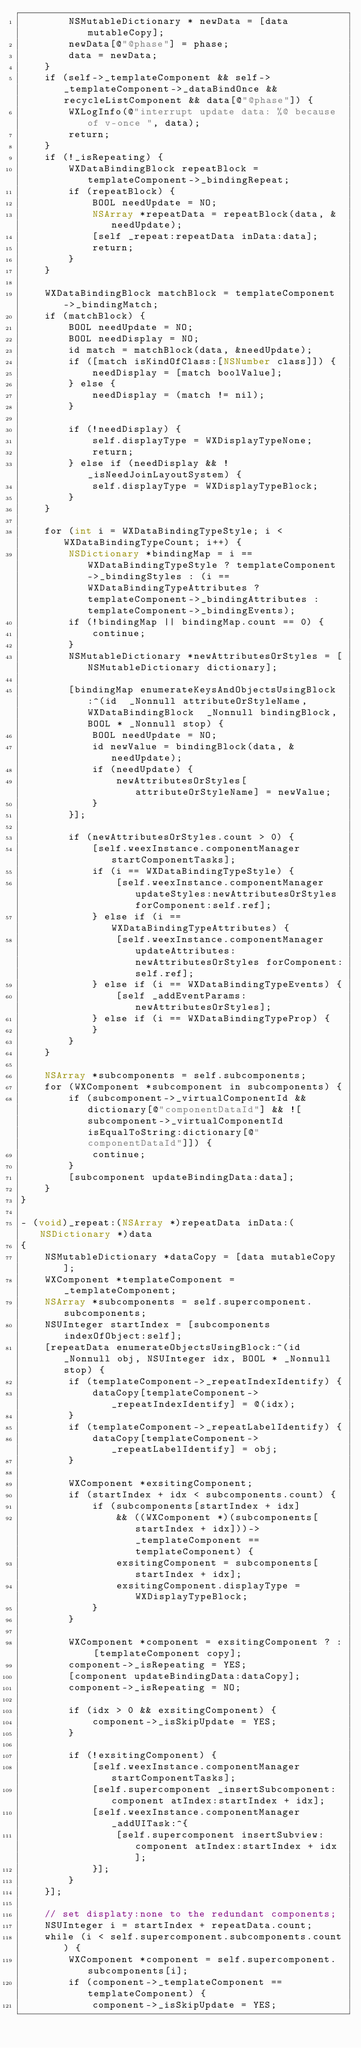Convert code to text. <code><loc_0><loc_0><loc_500><loc_500><_ObjectiveC_>        NSMutableDictionary * newData = [data mutableCopy];
        newData[@"@phase"] = phase;
        data = newData;
    }
    if (self->_templateComponent && self->_templateComponent->_dataBindOnce && recycleListComponent && data[@"@phase"]) {
        WXLogInfo(@"interrupt update data: %@ because of v-once ", data);
        return;
    }
    if (!_isRepeating) {
        WXDataBindingBlock repeatBlock = templateComponent->_bindingRepeat;
        if (repeatBlock) {
            BOOL needUpdate = NO;
            NSArray *repeatData = repeatBlock(data, &needUpdate);
            [self _repeat:repeatData inData:data];
            return;
        }
    }
    
    WXDataBindingBlock matchBlock = templateComponent->_bindingMatch;
    if (matchBlock) {
        BOOL needUpdate = NO;
        BOOL needDisplay = NO;
        id match = matchBlock(data, &needUpdate);
        if ([match isKindOfClass:[NSNumber class]]) {
            needDisplay = [match boolValue];
        } else {
            needDisplay = (match != nil);
        }
        
        if (!needDisplay) {
            self.displayType = WXDisplayTypeNone;
            return;
        } else if (needDisplay && !_isNeedJoinLayoutSystem) {
            self.displayType = WXDisplayTypeBlock;
        }
    }
    
    for (int i = WXDataBindingTypeStyle; i < WXDataBindingTypeCount; i++) {
        NSDictionary *bindingMap = i == WXDataBindingTypeStyle ? templateComponent->_bindingStyles : (i == WXDataBindingTypeAttributes ? templateComponent->_bindingAttributes : templateComponent->_bindingEvents);
        if (!bindingMap || bindingMap.count == 0) {
            continue;
        }
        NSMutableDictionary *newAttributesOrStyles = [NSMutableDictionary dictionary];
        
        [bindingMap enumerateKeysAndObjectsUsingBlock:^(id  _Nonnull attributeOrStyleName, WXDataBindingBlock  _Nonnull bindingBlock, BOOL * _Nonnull stop) {
            BOOL needUpdate = NO;
            id newValue = bindingBlock(data, &needUpdate);
            if (needUpdate) {
                newAttributesOrStyles[attributeOrStyleName] = newValue;
            }
        }];
        
        if (newAttributesOrStyles.count > 0) {
            [self.weexInstance.componentManager startComponentTasks];
            if (i == WXDataBindingTypeStyle) {
                [self.weexInstance.componentManager updateStyles:newAttributesOrStyles forComponent:self.ref];
            } else if (i == WXDataBindingTypeAttributes) {
                [self.weexInstance.componentManager updateAttributes:newAttributesOrStyles forComponent:self.ref];
            } else if (i == WXDataBindingTypeEvents) {
                [self _addEventParams:newAttributesOrStyles];
            } else if (i == WXDataBindingTypeProp) {
            }
        }
    }
    
    NSArray *subcomponents = self.subcomponents;
    for (WXComponent *subcomponent in subcomponents) {
        if (subcomponent->_virtualComponentId &&dictionary[@"componentDataId"] && ![subcomponent->_virtualComponentId isEqualToString:dictionary[@"componentDataId"]]) {
            continue;
        }
        [subcomponent updateBindingData:data];
    }
}

- (void)_repeat:(NSArray *)repeatData inData:(NSDictionary *)data
{
    NSMutableDictionary *dataCopy = [data mutableCopy];
    WXComponent *templateComponent = _templateComponent;
    NSArray *subcomponents = self.supercomponent.subcomponents;
    NSUInteger startIndex = [subcomponents indexOfObject:self];
    [repeatData enumerateObjectsUsingBlock:^(id  _Nonnull obj, NSUInteger idx, BOOL * _Nonnull stop) {
        if (templateComponent->_repeatIndexIdentify) {
            dataCopy[templateComponent->_repeatIndexIdentify] = @(idx);
        }
        if (templateComponent->_repeatLabelIdentify) {
            dataCopy[templateComponent->_repeatLabelIdentify] = obj;
        }
        
        WXComponent *exsitingComponent;
        if (startIndex + idx < subcomponents.count) {
            if (subcomponents[startIndex + idx]
                && ((WXComponent *)(subcomponents[startIndex + idx]))->_templateComponent == templateComponent) {
                exsitingComponent = subcomponents[startIndex + idx];
                exsitingComponent.displayType = WXDisplayTypeBlock;
            }
        }
        
        WXComponent *component = exsitingComponent ? : [templateComponent copy];
        component->_isRepeating = YES;
        [component updateBindingData:dataCopy];
        component->_isRepeating = NO;
        
        if (idx > 0 && exsitingComponent) {
            component->_isSkipUpdate = YES;
        }
        
        if (!exsitingComponent) {
            [self.weexInstance.componentManager startComponentTasks];
            [self.supercomponent _insertSubcomponent:component atIndex:startIndex + idx];
            [self.weexInstance.componentManager _addUITask:^{
                [self.supercomponent insertSubview:component atIndex:startIndex + idx];
            }];
        }
    }];
    
    // set displaty:none to the redundant components;
    NSUInteger i = startIndex + repeatData.count;
    while (i < self.supercomponent.subcomponents.count) {
        WXComponent *component = self.supercomponent.subcomponents[i];
        if (component->_templateComponent == templateComponent) {
            component->_isSkipUpdate = YES;</code> 